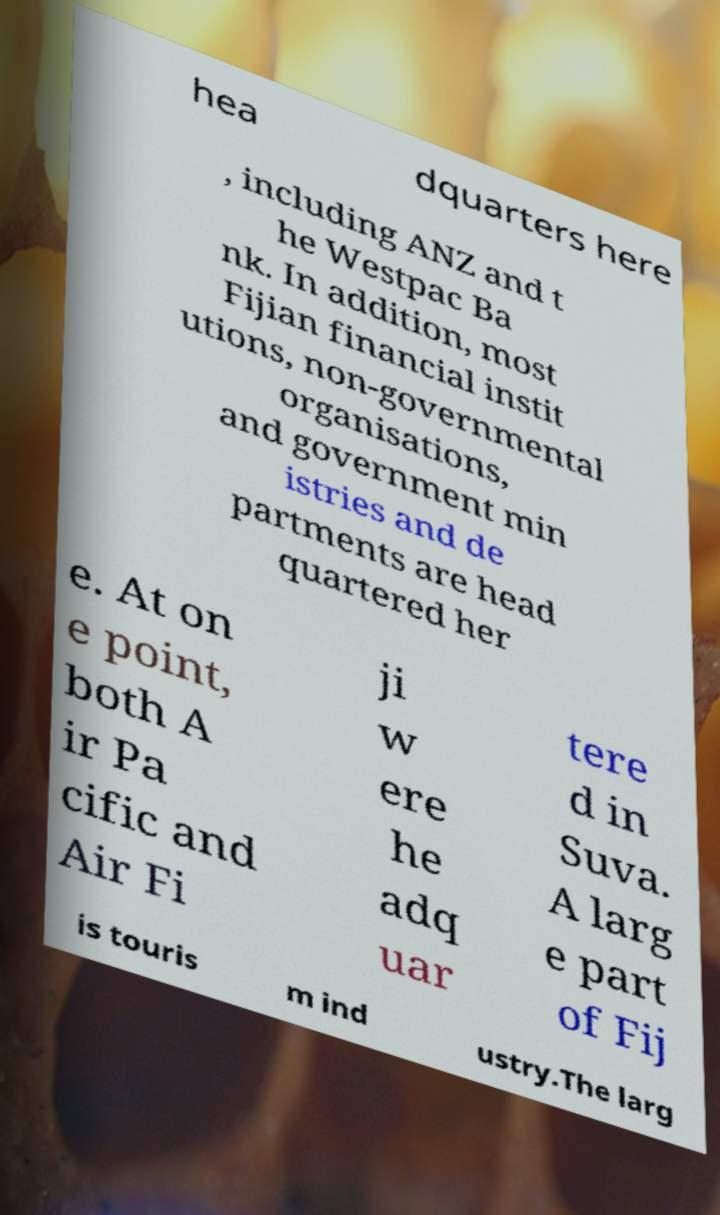Could you extract and type out the text from this image? hea dquarters here , including ANZ and t he Westpac Ba nk. In addition, most Fijian financial instit utions, non-governmental organisations, and government min istries and de partments are head quartered her e. At on e point, both A ir Pa cific and Air Fi ji w ere he adq uar tere d in Suva. A larg e part of Fij is touris m ind ustry.The larg 